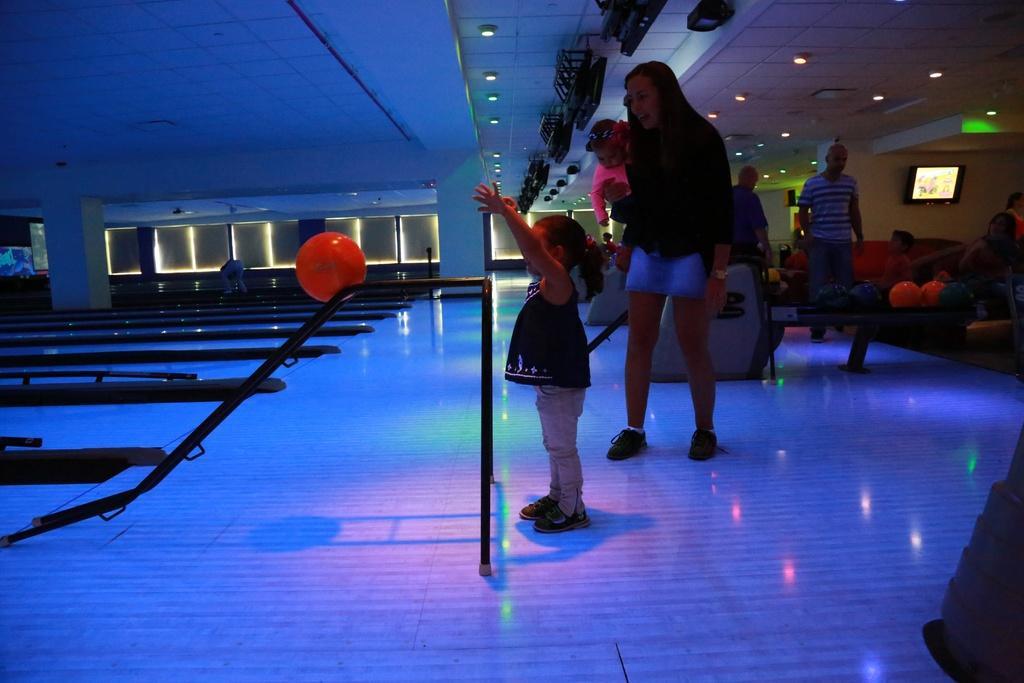Please provide a concise description of this image. On the left side, there is an orange color ball on a ladder. On the right side, there are persons on the floor. In the background, there are lights and screens attached to the roof, there is a sofa and there are other objects. 